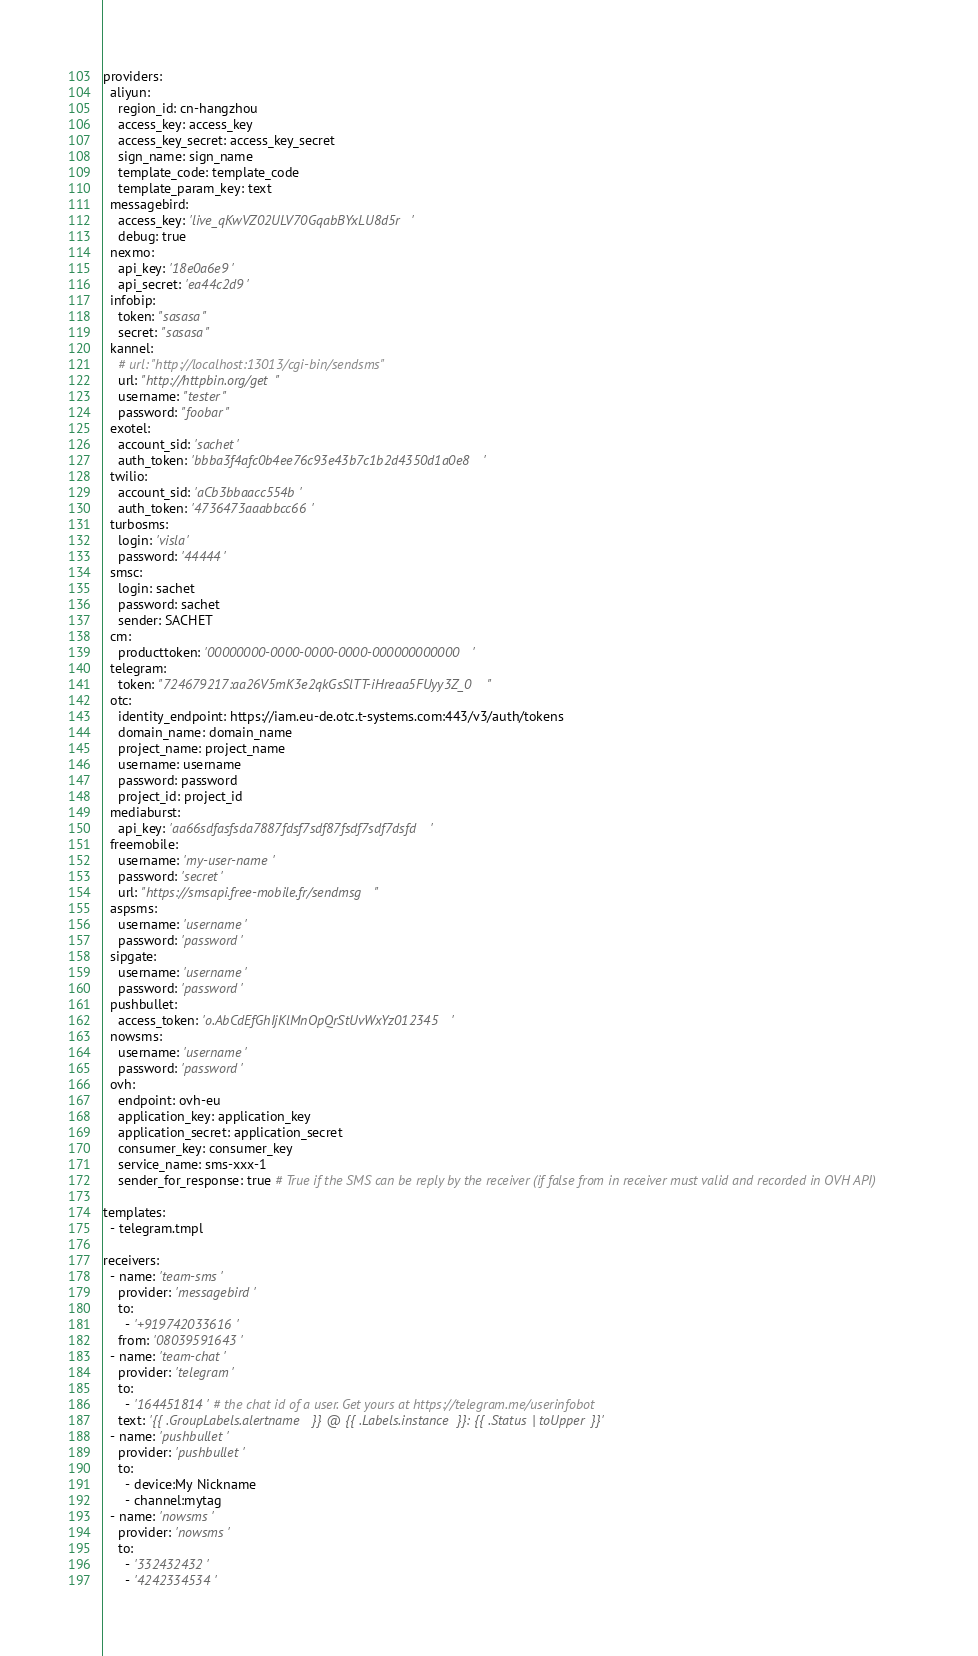<code> <loc_0><loc_0><loc_500><loc_500><_YAML_>providers:
  aliyun:
    region_id: cn-hangzhou
    access_key: access_key
    access_key_secret: access_key_secret
    sign_name: sign_name
    template_code: template_code
    template_param_key: text
  messagebird:
    access_key: 'live_qKwVZ02ULV70GqabBYxLU8d5r'
    debug: true
  nexmo:
    api_key: '18e0a6e9'
    api_secret: 'ea44c2d9'
  infobip:
    token: "sasasa"
    secret: "sasasa"
  kannel:
    # url: "http://localhost:13013/cgi-bin/sendsms"
    url: "http://httpbin.org/get"
    username: "tester"
    password: "foobar"
  exotel:
    account_sid: 'sachet'
    auth_token: 'bbba3f4afc0b4ee76c93e43b7c1b2d4350d1a0e8'
  twilio:
    account_sid: 'aCb3bbaacc554b'
    auth_token: '4736473aaabbcc66'
  turbosms:
    login: 'visla'
    password: '44444'
  smsc:
    login: sachet
    password: sachet
    sender: SACHET
  cm:
    producttoken: '00000000-0000-0000-0000-000000000000'
  telegram:
    token: "724679217:aa26V5mK3e2qkGsSlTT-iHreaa5FUyy3Z_0"
  otc:
    identity_endpoint: https://iam.eu-de.otc.t-systems.com:443/v3/auth/tokens
    domain_name: domain_name
    project_name: project_name
    username: username
    password: password
    project_id: project_id
  mediaburst:
    api_key: 'aa66sdfasfsda7887fdsf7sdf87fsdf7sdf7dsfd'
  freemobile:
    username: 'my-user-name'
    password: 'secret'
    url: "https://smsapi.free-mobile.fr/sendmsg"
  aspsms:
    username: 'username'
    password: 'password'
  sipgate:
    username: 'username'
    password: 'password'
  pushbullet:
    access_token: 'o.AbCdEfGhIjKlMnOpQrStUvWxYz012345'
  nowsms:
    username: 'username'
    password: 'password'
  ovh:
    endpoint: ovh-eu
    application_key: application_key
    application_secret: application_secret
    consumer_key: consumer_key
    service_name: sms-xxx-1
    sender_for_response: true # True if the SMS can be reply by the receiver (if false from in receiver must valid and recorded in OVH API)

templates:
  - telegram.tmpl

receivers:
  - name: 'team-sms'
    provider: 'messagebird'
    to:
      - '+919742033616'
    from: '08039591643'
  - name: 'team-chat'
    provider: 'telegram'
    to:
      - '164451814' # the chat id of a user. Get yours at https://telegram.me/userinfobot
    text: '{{ .GroupLabels.alertname }} @ {{ .Labels.instance }}: {{ .Status | toUpper }}'
  - name: 'pushbullet'
    provider: 'pushbullet'
    to:
      - device:My Nickname
      - channel:mytag
  - name: 'nowsms'
    provider: 'nowsms'
    to:
      - '332432432'
      - '4242334534'
</code> 